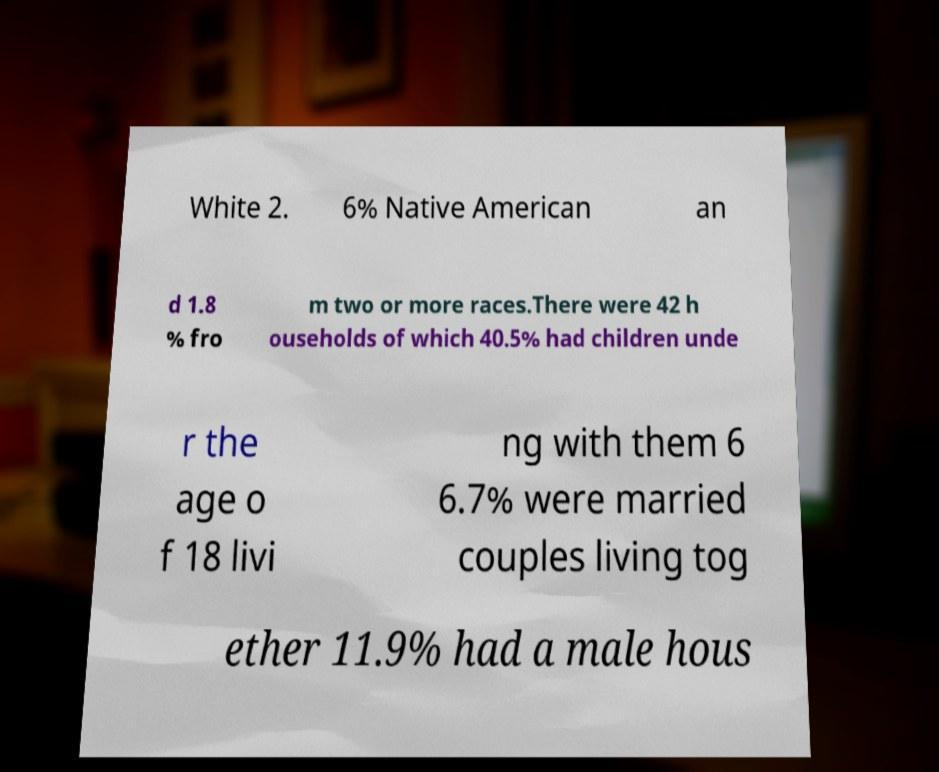What messages or text are displayed in this image? I need them in a readable, typed format. White 2. 6% Native American an d 1.8 % fro m two or more races.There were 42 h ouseholds of which 40.5% had children unde r the age o f 18 livi ng with them 6 6.7% were married couples living tog ether 11.9% had a male hous 